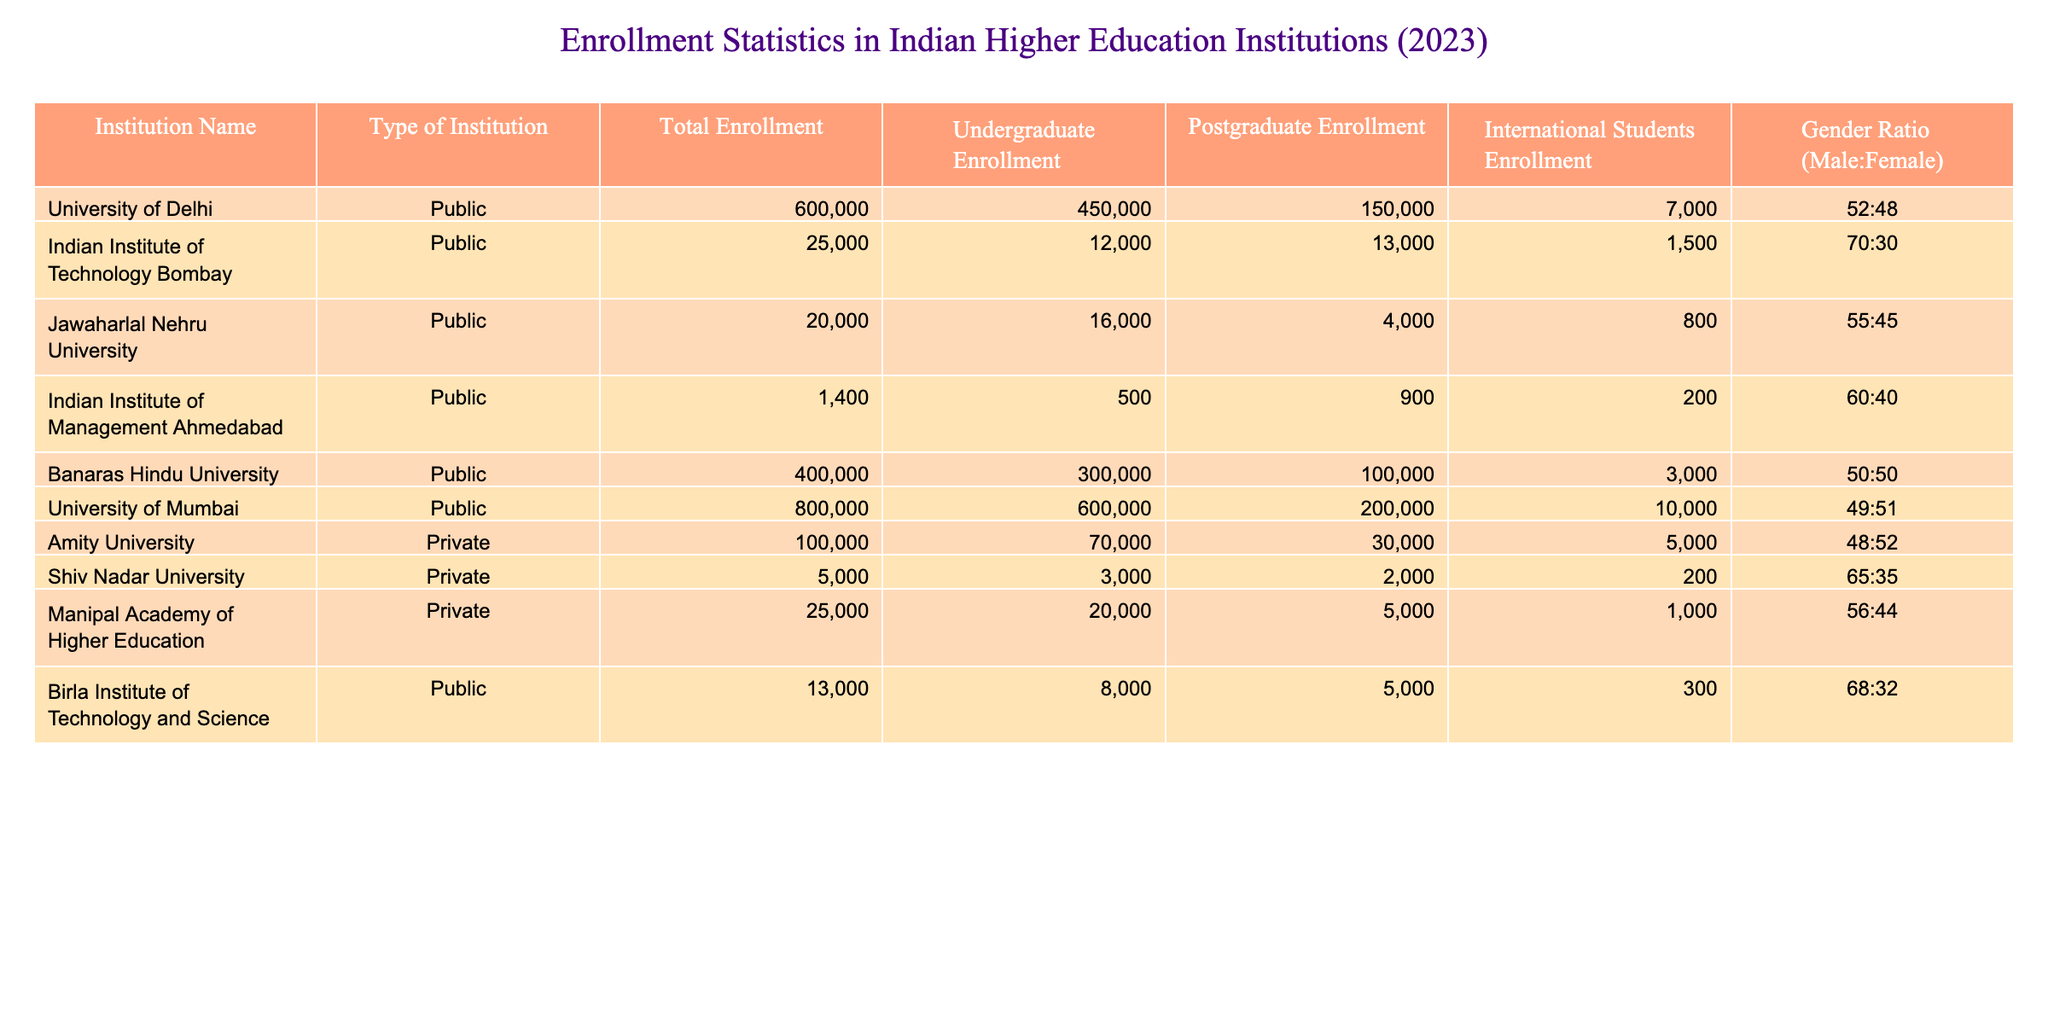What is the total enrollment at the University of Delhi? The total enrollment at the University of Delhi is given directly in the table as 600,000 students.
Answer: 600,000 Which institution has the highest number of international students? By comparing the "International Students Enrollment" figures from the table, the University of Delhi has the highest with 7,000 international students.
Answer: University of Delhi What is the total enrollment for private institutions listed in the table? The private institutions are Amity University and Shiv Nadar University with enrollments of 100,000 and 5,000 respectively, so the total is 100,000 + 5,000 = 105,000.
Answer: 105,000 Is the gender ratio at Banaras Hindu University equal for male and female students? The gender ratio at Banaras Hindu University is listed as 50:50, indicating an equal distribution of male and female students.
Answer: Yes What is the average postgraduate enrollment across all institutions listed? The postgraduate enrollments are 150,000, 13,000, 4,000, 900, 100,000, 200,000, 30,000, 2,000, 5,000. Adding these gives 150,000 + 13,000 + 4,000 + 900 + 100,000 + 200,000 + 30,000 + 2,000 + 5,000 = 505,900. There are 9 institutions, so the average is 505,900 / 9 = 56,211.11, which we round to 56,211.
Answer: 56,211 Which university has a higher undergraduate enrollment: the Indian Institute of Technology Bombay or Jawaharlal Nehru University? The undergraduate enrollment at IIT Bombay is 12,000, while Jawaharlal Nehru University's is 16,000. Thus, JNU has a higher enrollment.
Answer: Jawaharlal Nehru University If we consider only public institutions, what is the total enrollment of students? The public institutions listed are the University of Delhi, IIT Bombay, JNU, IIM Ahmedabad, Banaras Hindu University, University of Mumbai, and BITS. Adding their total enrollments: 600,000 + 25,000 + 20,000 + 1,400 + 400,000 + 800,000 + 13,000 = 2,059,400.
Answer: 2,059,400 Based on the gender ratios, which institution has a higher percentage of female students? By analyzing the gender ratios, the institution with the highest percentage of female students is Amity University with a ratio of 48:52 (female percentage = 52%).
Answer: Amity University 